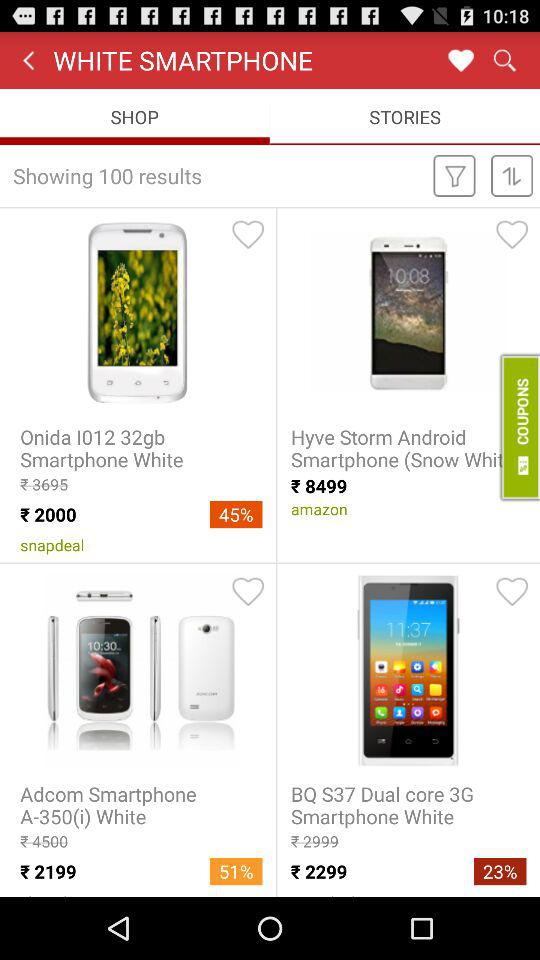Which tab is currently selected? The currently selected tab is "SHOP". 